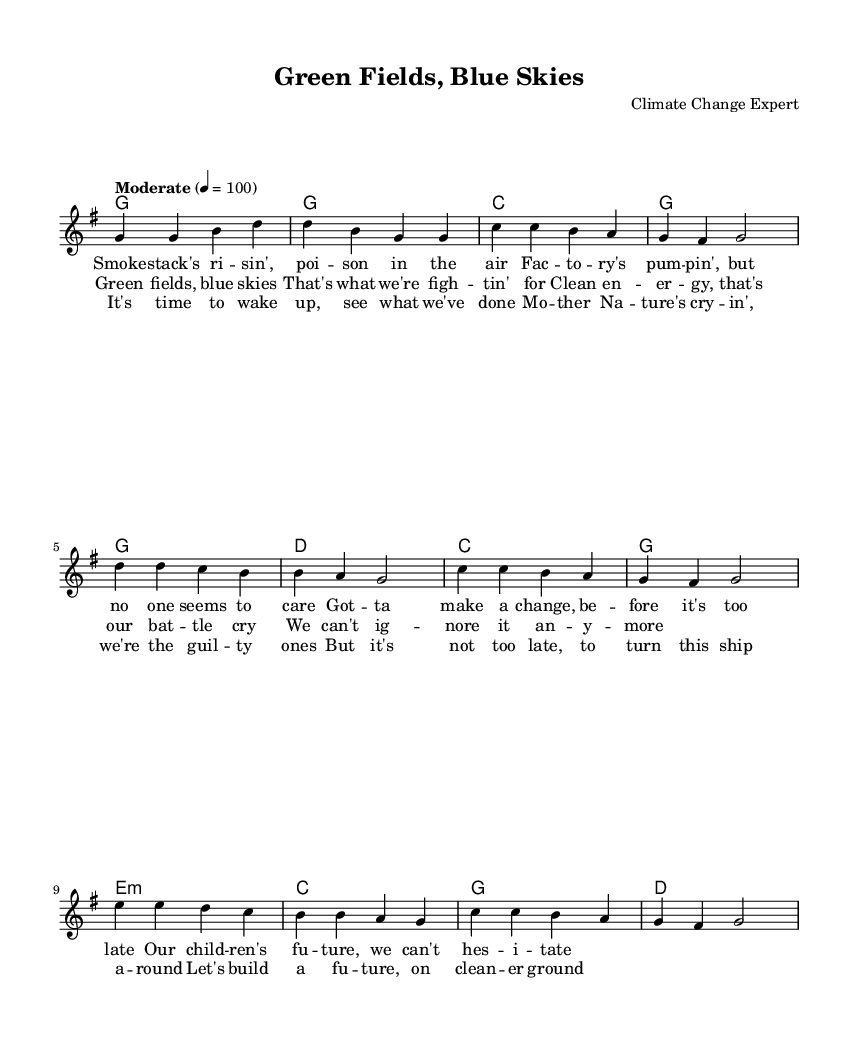What is the key signature of this music? The key signature is G major, which has one sharp (F#). This can be identified from the global settings of the score where it states '\key g \major'.
Answer: G major What is the time signature of the piece? The time signature is 4/4, as indicated in the global settings where it states '\time 4/4'. This means there are four beats in each measure and the quarter note gets one beat.
Answer: 4/4 What is the tempo marking for this piece? The tempo marking is "Moderate" with a metronome marking of 4 = 100, meaning it is to be played at a moderate speed of 100 beats per minute. This is clearly stated in the global settings with '\tempo "Moderate" 4 = 100'.
Answer: Moderate How many verses are there in the lyrics? The lyrics are divided into three sections: verse, chorus, and bridge. There is one verse provided in the data, which is clearly labeled as 'verseOne'.
Answer: One What musical form does the song follow? The song follows the structure of verse-chorus-bridge, which is common in country music. This is evident from the organization of the sections in the code: the melody is divided into 'verse', 'chorus', and 'bridge'.
Answer: Verse-Chorus-Bridge What is the primary theme of the song's lyrics? The primary theme is environmental advocacy, particularly addressing industrial pollution and promoting clean energy. This can be gathered from the lyrics provided, which mention pollution, the future of children, and the call to fight for green fields and blue skies.
Answer: Environmental advocacy 